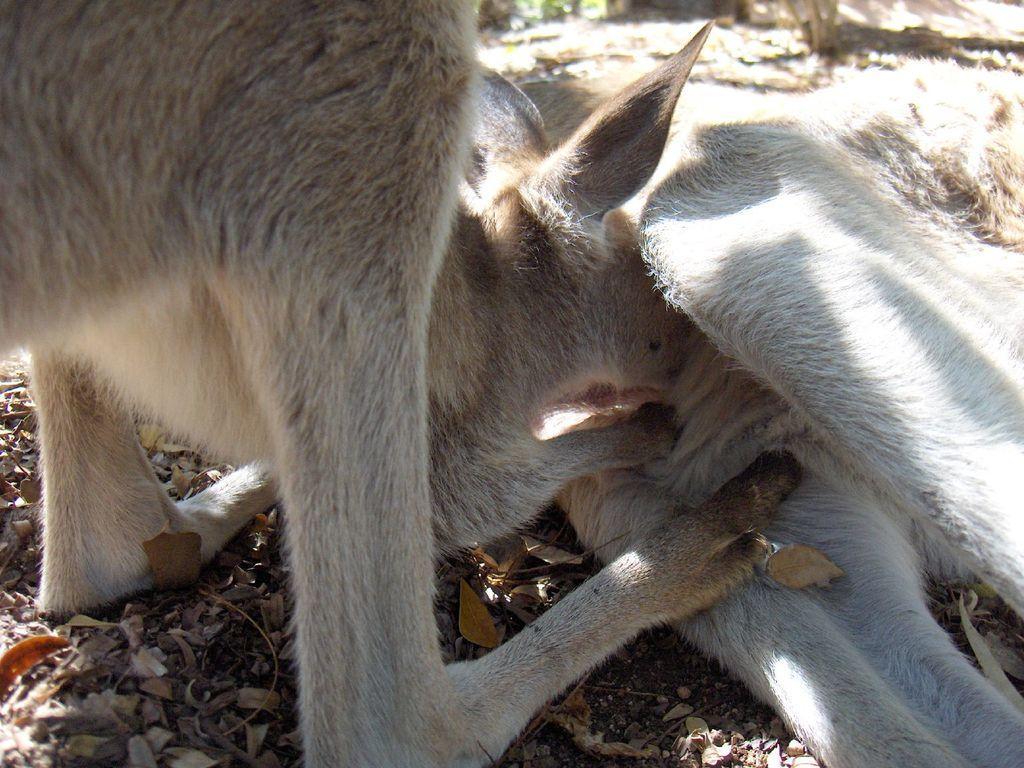How many animals are present in the image? There are two animals in the image. What is the position of the animals in the image? The animals are on the ground. What type of division is being performed by the gold ducks in the image? There are no ducks, gold or otherwise, present in the image, and therefore no division is being performed. 